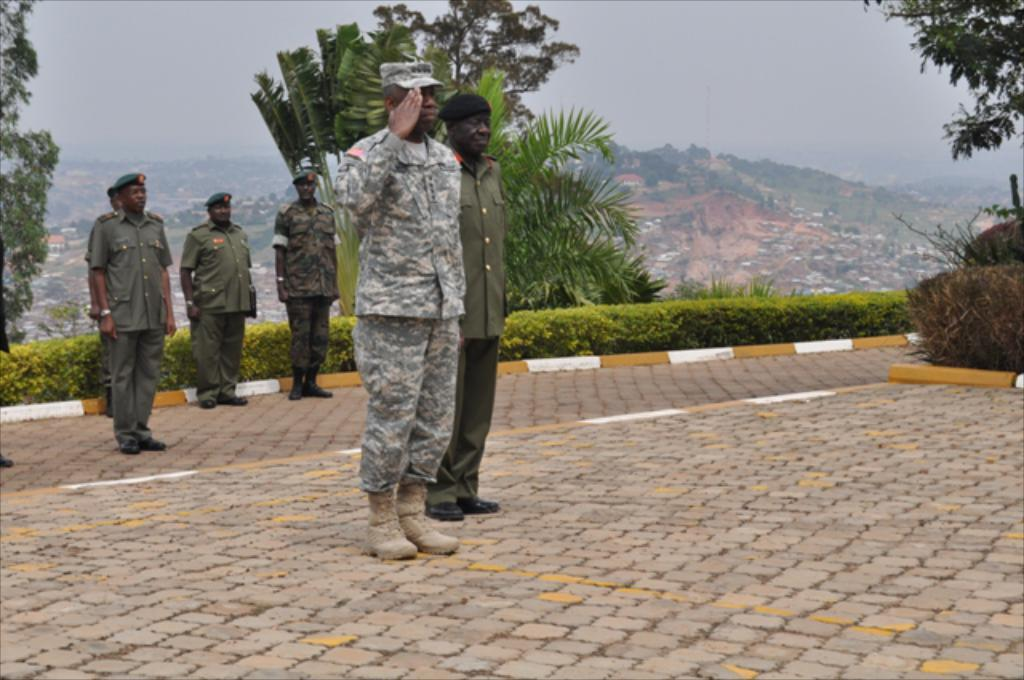What are the people in the image doing? The people in the image are standing on the road. What type of vegetation can be seen in the image? There are plants and trees visible in the image. What is the landscape feature in the background of the image? There is a mountain in the background of the image. What is the opinion of the brother on the team in the image? There is no brother or team present in the image, so it is not possible to determine their opinion. 